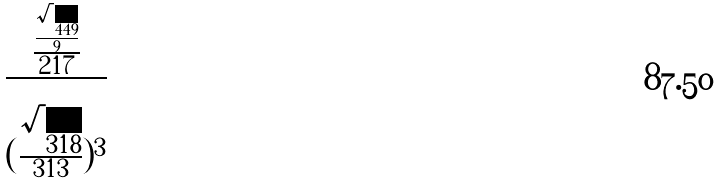<formula> <loc_0><loc_0><loc_500><loc_500>\frac { \frac { \frac { \sqrt { 4 4 9 } } { 9 } } { 2 1 7 } } { ( \frac { \sqrt { 3 1 8 } } { 3 1 3 } ) ^ { 3 } }</formula> 